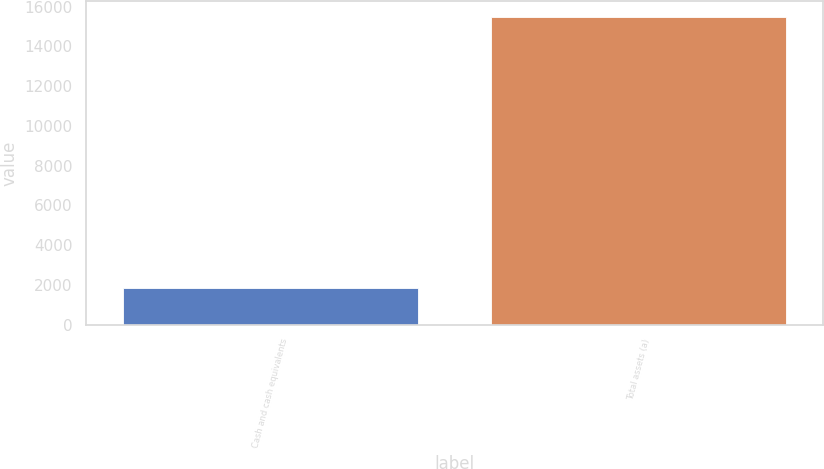Convert chart. <chart><loc_0><loc_0><loc_500><loc_500><bar_chart><fcel>Cash and cash equivalents<fcel>Total assets (a)<nl><fcel>1832<fcel>15483<nl></chart> 